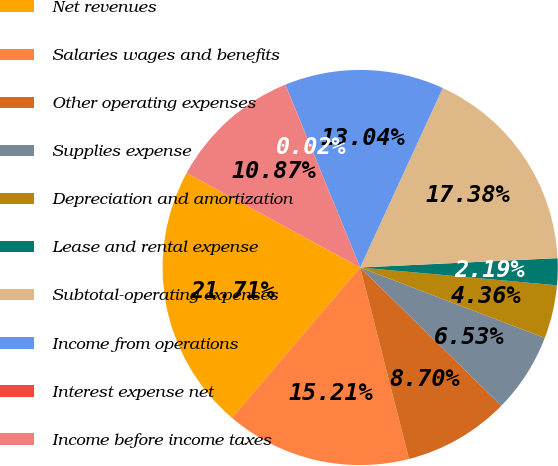<chart> <loc_0><loc_0><loc_500><loc_500><pie_chart><fcel>Net revenues<fcel>Salaries wages and benefits<fcel>Other operating expenses<fcel>Supplies expense<fcel>Depreciation and amortization<fcel>Lease and rental expense<fcel>Subtotal-operating expenses<fcel>Income from operations<fcel>Interest expense net<fcel>Income before income taxes<nl><fcel>21.71%<fcel>15.21%<fcel>8.7%<fcel>6.53%<fcel>4.36%<fcel>2.19%<fcel>17.38%<fcel>13.04%<fcel>0.02%<fcel>10.87%<nl></chart> 